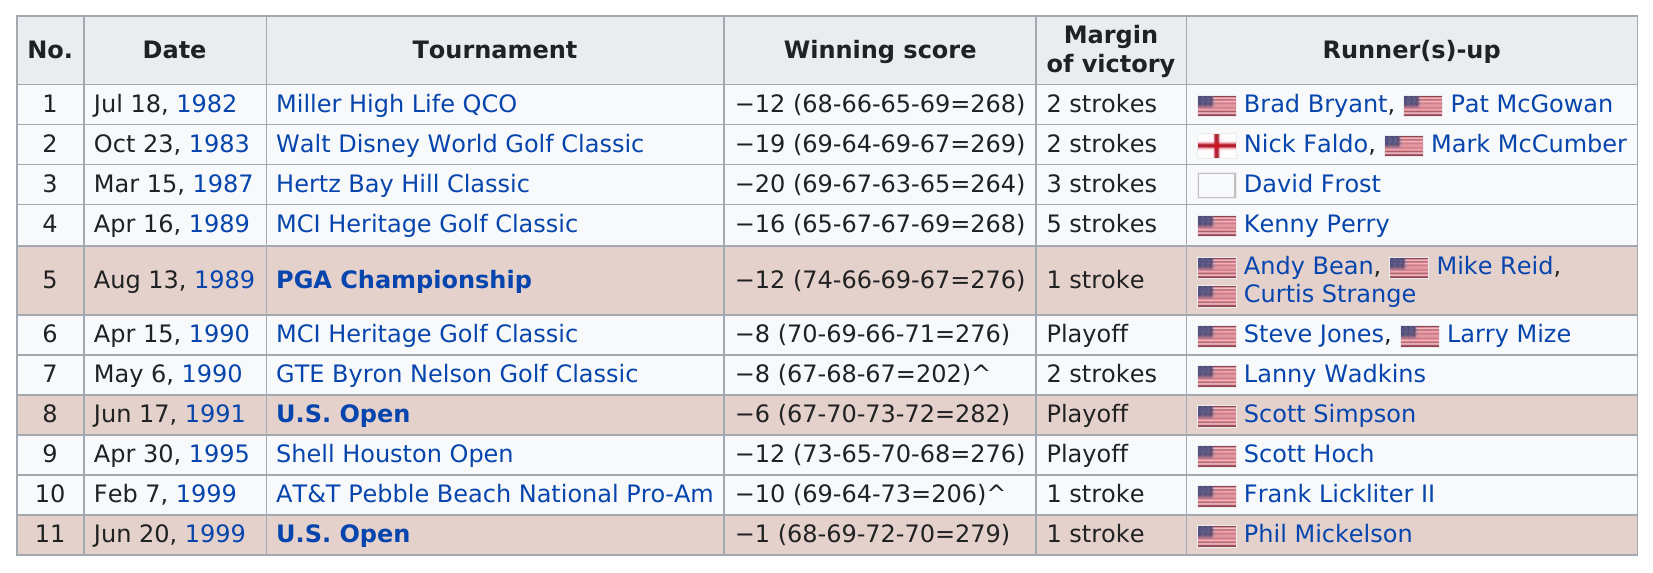Indicate a few pertinent items in this graphic. In April, he achieved a total of 3 victories. Besides Brad Bryant, who was the other runner-up in the 1982 Miller High Life QCO? The answer is Pat McGowan. Scott Simpson was runner-up to him a total of 1 time. The most tournaments were held in April. The margin of victory was 3 strokes or more on two occasions during the season. 